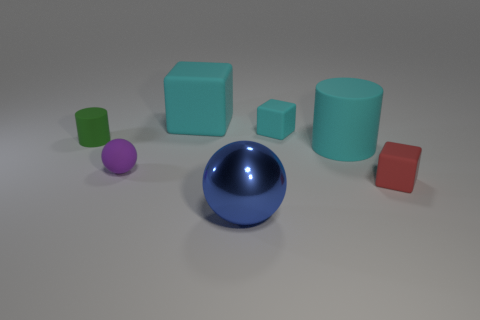What color is the large thing that is the same shape as the tiny purple matte thing? blue 